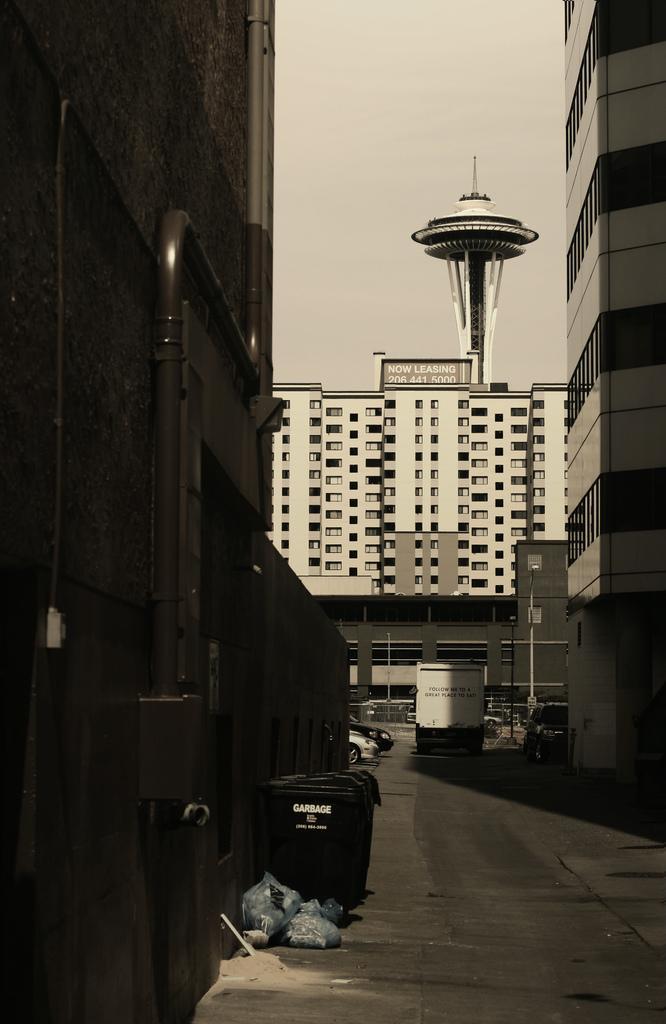Could you give a brief overview of what you see in this image? In this picture we can see a dustbin and a few covers on the path. We can see some vehicles on the road. There are a few buildings and a tower in the background. 